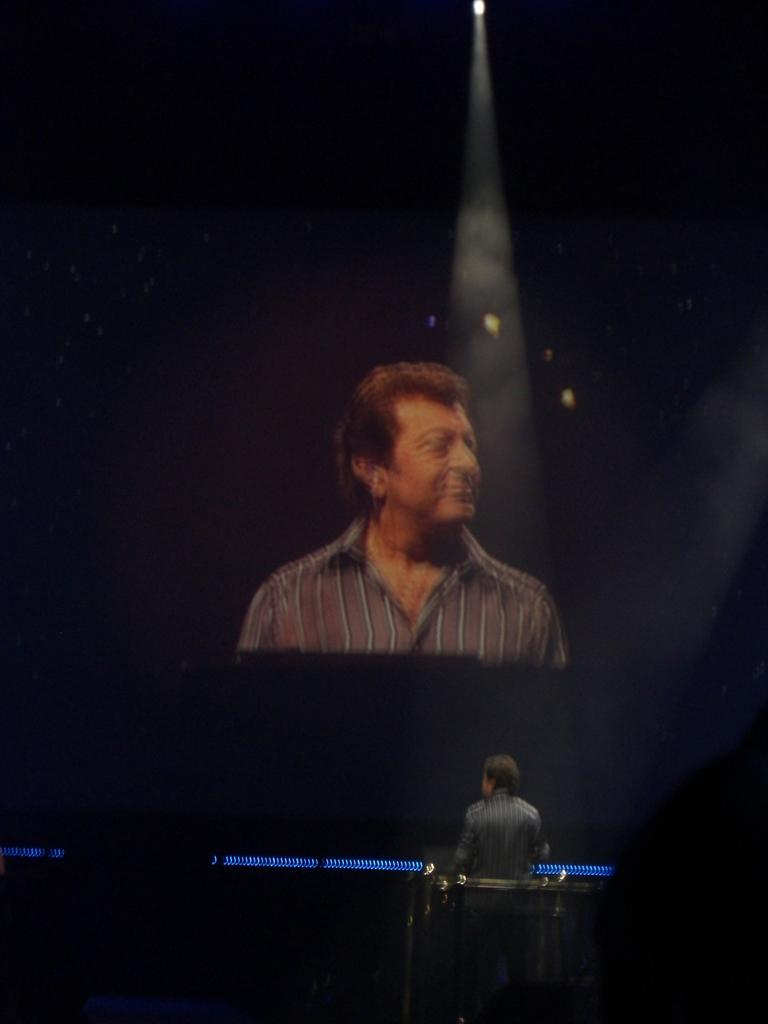Who or what is located in the front of the image? There is a person in the front of the image. What can be seen in the background of the image? There is a screen in the background of the image. What is displayed on the screen? Another person is visible on the screen. Can you describe the lighting in the image? There is a light at the top of the image. Where is the place located in the image? There is no mention of a "place" in the image. --- Facts: 1. There is a person in the image. 2. The person is holding a book. 3. The book has a blue cover. 4. The person is sitting on a chair. 5. There is a table next to the chair. Absurd Topics: elephant, piano, ocean Conversation: Who or what is the main subject in the image? There is a person in the image. What is the person holding in the image? The person is holding a book. Can you describe the book's cover? The book has a blue cover. What is the person's posture in the image? The person is sitting on a chair. Can you describe the setting in the image? There is a table next to the chair. Reasoning: Let's think step by step in order to produce the conversation. We start by identifying the main subject in the image, which is the person. Then, we describe what the person is holding, which is a book with a blue cover. Next, we observe the person's posture, which is sitting on a chair. Finally, we describe the setting in the image, which includes a table next to the chair. Absurd Question/Answer: Can you hear the elephant playing the piano in the image? There is no mention of an elephant, a piano, or an ocean in the image. 